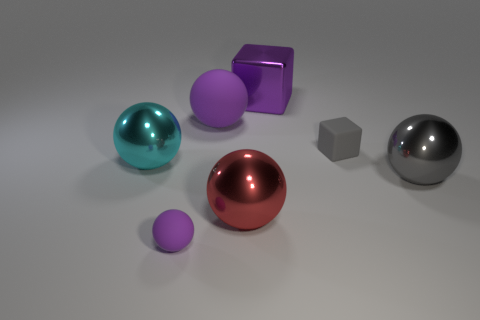If the objects had weights, which would be the heaviest and lightest? If we were to theorize based on their sizes and assuming all objects are made of similar materials, the largest sphere would likely be the heaviest due to its volume, while the smallest one could be the lightest. 